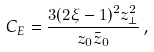<formula> <loc_0><loc_0><loc_500><loc_500>C _ { E } = \frac { 3 ( 2 \xi - 1 ) ^ { 2 } z _ { \perp } ^ { 2 } } { z _ { 0 } { \bar { z } } _ { 0 } } \, ,</formula> 